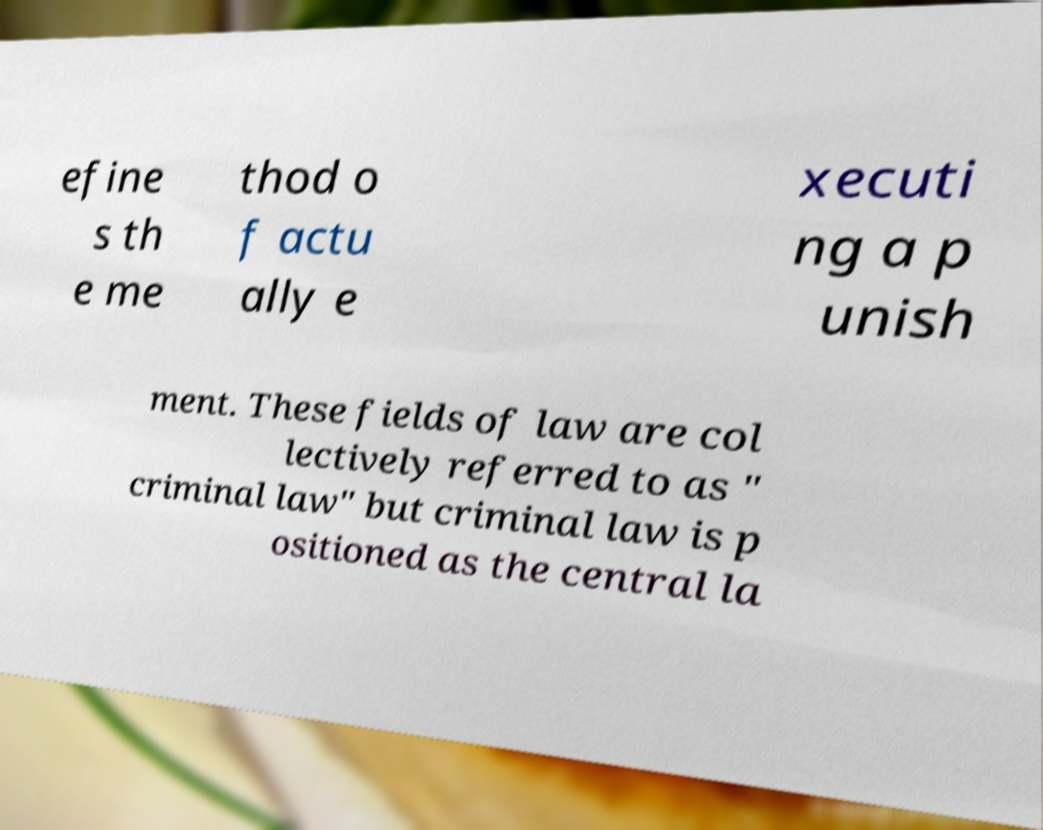Could you assist in decoding the text presented in this image and type it out clearly? efine s th e me thod o f actu ally e xecuti ng a p unish ment. These fields of law are col lectively referred to as " criminal law" but criminal law is p ositioned as the central la 